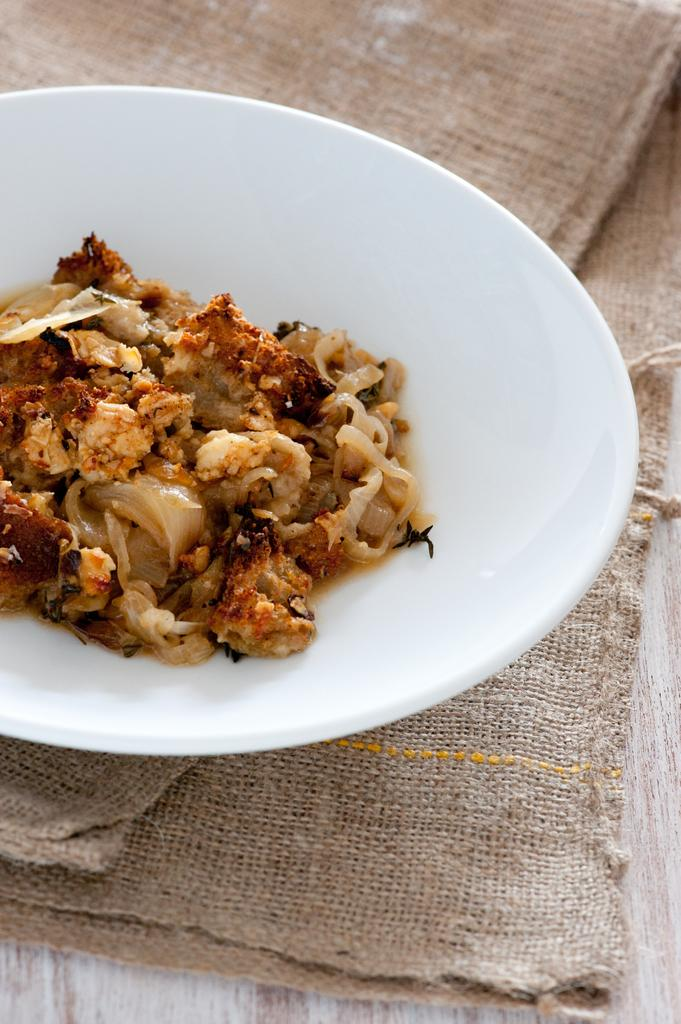What is the main subject of the image? The main subject of the image is an edible. Can you describe the plate on which the edible is placed? The edible is placed on a white color plate. How many girls are visible in the image? There are no girls present in the image; it features an edible on a white color plate. What type of net is used to catch the edible in the image? There is no net present in the image, and the edible is not being caught. 